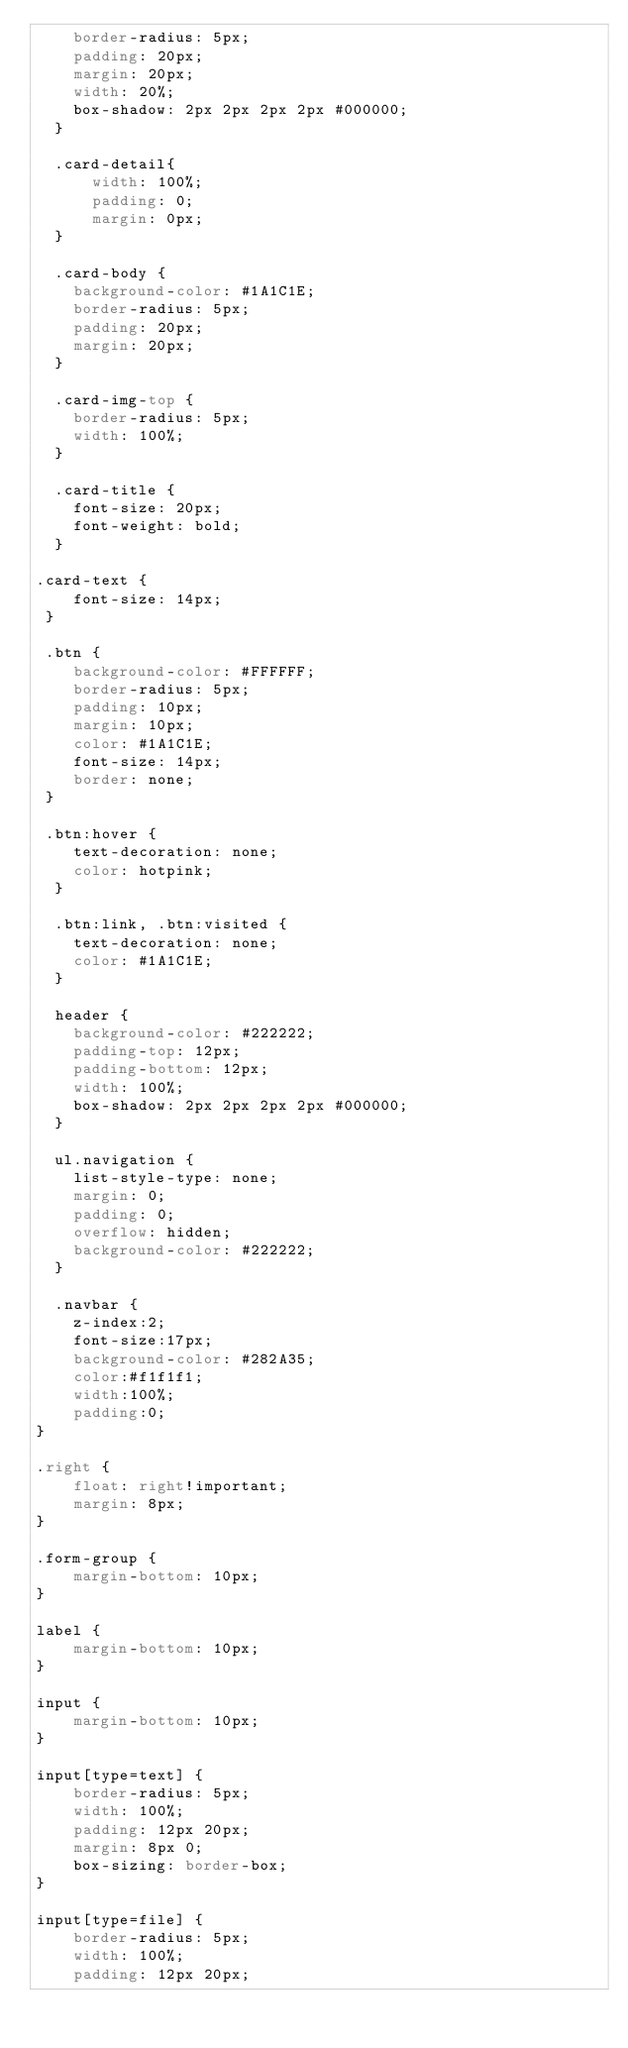Convert code to text. <code><loc_0><loc_0><loc_500><loc_500><_CSS_>    border-radius: 5px;
    padding: 20px;
    margin: 20px;
    width: 20%;
    box-shadow: 2px 2px 2px 2px #000000;
  }

  .card-detail{
      width: 100%;
      padding: 0;
      margin: 0px;
  }

  .card-body {
    background-color: #1A1C1E;
    border-radius: 5px;
    padding: 20px;
    margin: 20px;
  }

  .card-img-top {
    border-radius: 5px;
    width: 100%;
  }

  .card-title {
    font-size: 20px;
    font-weight: bold;
  }

.card-text {
    font-size: 14px;
 }

 .btn {
    background-color: #FFFFFF;
    border-radius: 5px;
    padding: 10px;
    margin: 10px;
    color: #1A1C1E;
    font-size: 14px;
    border: none;
 }

 .btn:hover {
    text-decoration: none;
    color: hotpink;
  }

  .btn:link, .btn:visited {
    text-decoration: none;
    color: #1A1C1E;
  }

  header {
    background-color: #222222;
    padding-top: 12px;
    padding-bottom: 12px;
    width: 100%;
    box-shadow: 2px 2px 2px 2px #000000;
  }

  ul.navigation {
    list-style-type: none;
    margin: 0;
    padding: 0;
    overflow: hidden;
    background-color: #222222;
  }

  .navbar {
    z-index:2;
    font-size:17px;
    background-color: #282A35;
    color:#f1f1f1;
    width:100%;
    padding:0;
}

.right {
    float: right!important;
    margin: 8px;
}

.form-group {
    margin-bottom: 10px;
}

label {
    margin-bottom: 10px;
}

input {
    margin-bottom: 10px;
}

input[type=text] {
    border-radius: 5px;
    width: 100%;
    padding: 12px 20px;
    margin: 8px 0;
    box-sizing: border-box;
}

input[type=file] {
    border-radius: 5px;
    width: 100%;
    padding: 12px 20px;</code> 